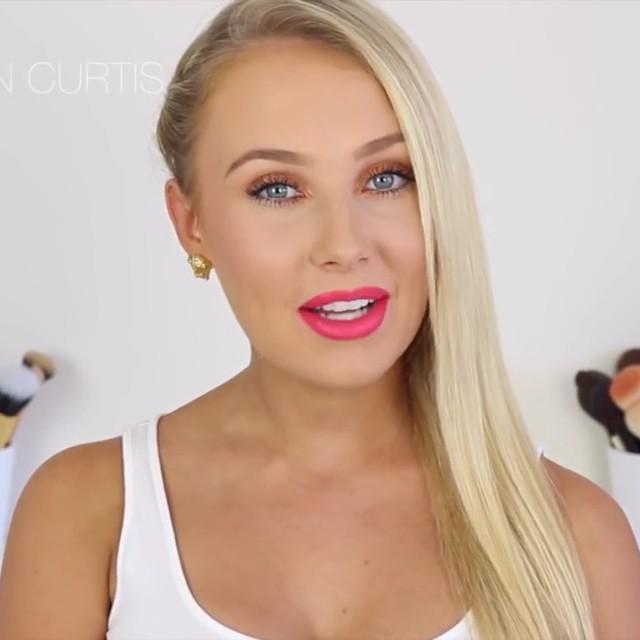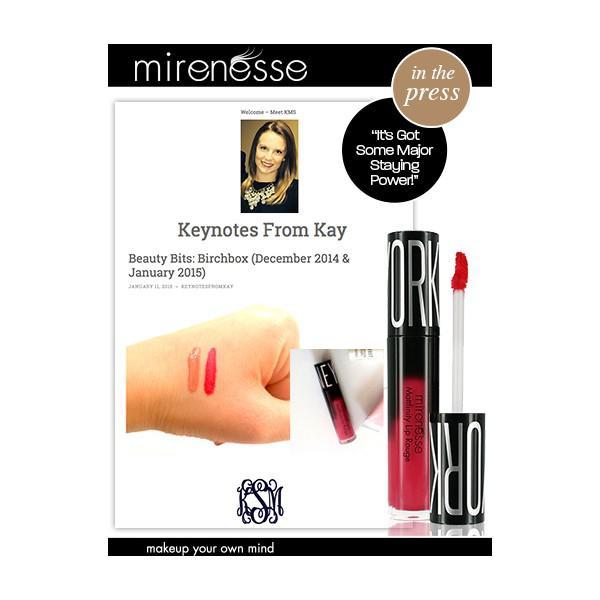The first image is the image on the left, the second image is the image on the right. Given the left and right images, does the statement "One image shows lipstick on skin that is not lips." hold true? Answer yes or no. Yes. The first image is the image on the left, the second image is the image on the right. For the images shown, is this caption "Right image shows a model's face on black next to a lipstick brush and tube." true? Answer yes or no. No. 